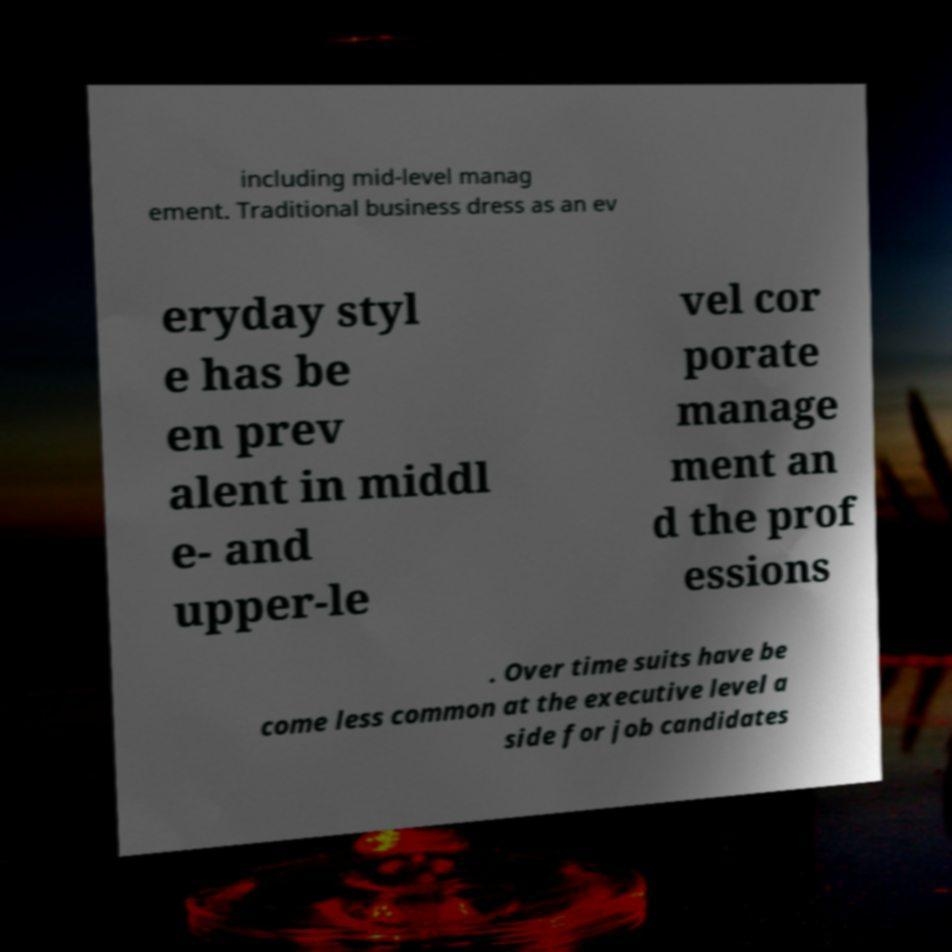Please read and relay the text visible in this image. What does it say? including mid-level manag ement. Traditional business dress as an ev eryday styl e has be en prev alent in middl e- and upper-le vel cor porate manage ment an d the prof essions . Over time suits have be come less common at the executive level a side for job candidates 